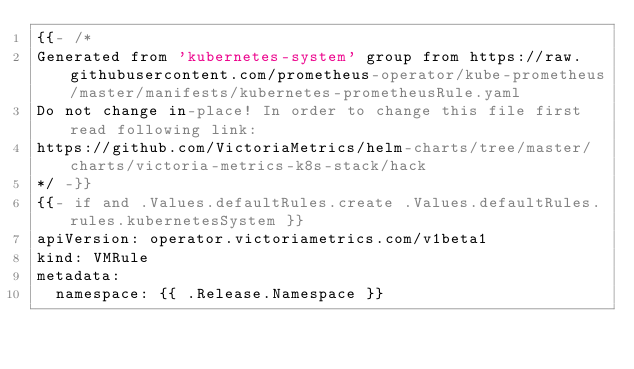Convert code to text. <code><loc_0><loc_0><loc_500><loc_500><_YAML_>{{- /*
Generated from 'kubernetes-system' group from https://raw.githubusercontent.com/prometheus-operator/kube-prometheus/master/manifests/kubernetes-prometheusRule.yaml
Do not change in-place! In order to change this file first read following link:
https://github.com/VictoriaMetrics/helm-charts/tree/master/charts/victoria-metrics-k8s-stack/hack
*/ -}}
{{- if and .Values.defaultRules.create .Values.defaultRules.rules.kubernetesSystem }}
apiVersion: operator.victoriametrics.com/v1beta1
kind: VMRule
metadata:
  namespace: {{ .Release.Namespace }}</code> 